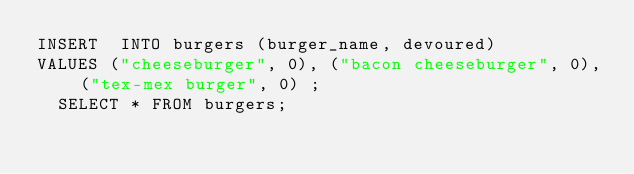<code> <loc_0><loc_0><loc_500><loc_500><_SQL_>INSERT  INTO burgers (burger_name, devoured)
VALUES ("cheeseburger", 0), ("bacon cheeseburger", 0), ("tex-mex burger", 0) ;
  SELECT * FROM burgers;
</code> 